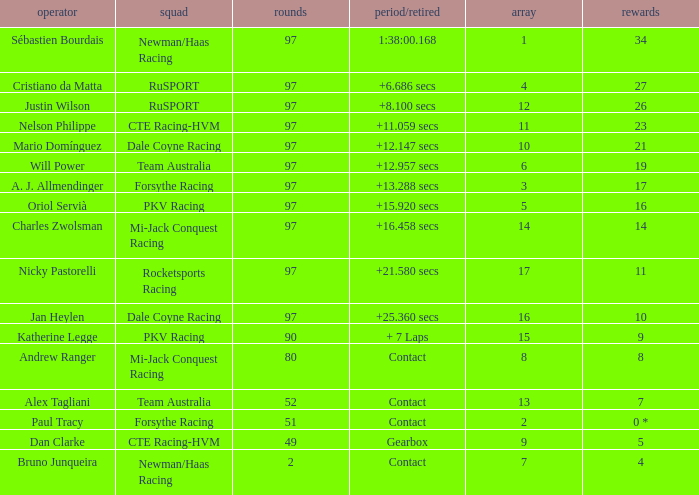What team does jan heylen race for? Dale Coyne Racing. 